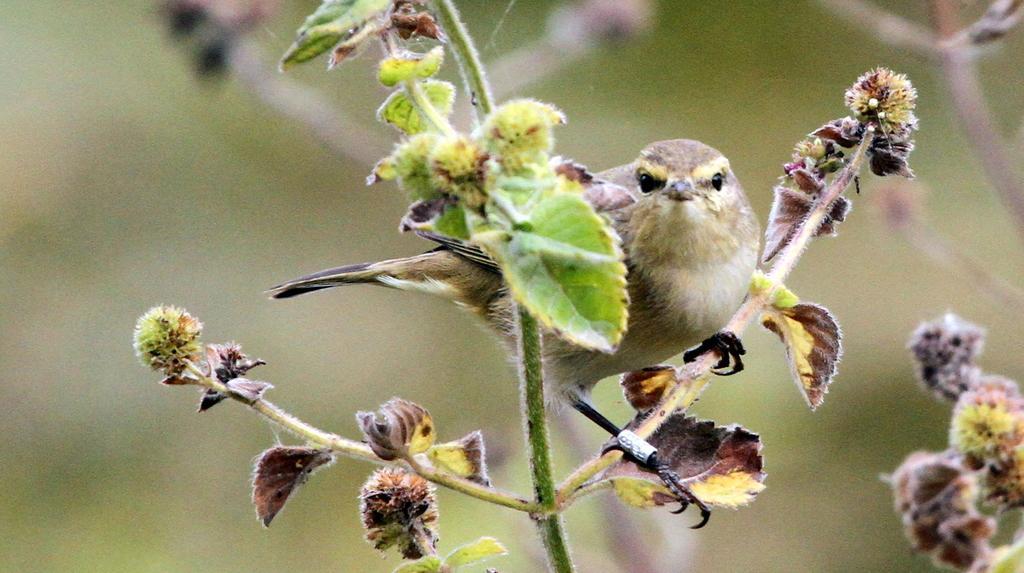Could you give a brief overview of what you see in this image? In this image I can see a sparrow is sitting on the stem of a plant. 